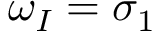Convert formula to latex. <formula><loc_0><loc_0><loc_500><loc_500>\omega _ { I } = \sigma _ { 1 }</formula> 